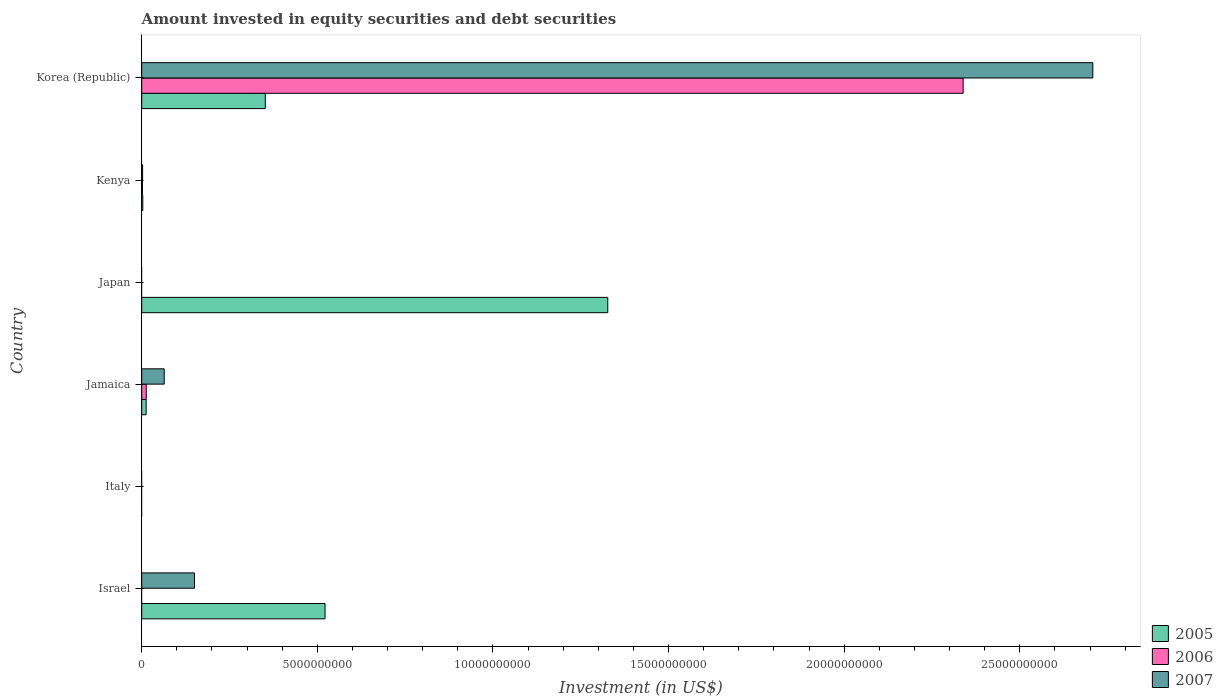How many bars are there on the 5th tick from the top?
Make the answer very short. 0. How many bars are there on the 2nd tick from the bottom?
Provide a succinct answer. 0. In how many cases, is the number of bars for a given country not equal to the number of legend labels?
Make the answer very short. 3. What is the amount invested in equity securities and debt securities in 2007 in Korea (Republic)?
Your answer should be compact. 2.71e+1. Across all countries, what is the maximum amount invested in equity securities and debt securities in 2007?
Provide a short and direct response. 2.71e+1. What is the total amount invested in equity securities and debt securities in 2005 in the graph?
Offer a terse response. 2.22e+1. What is the difference between the amount invested in equity securities and debt securities in 2005 in Japan and that in Kenya?
Provide a short and direct response. 1.32e+1. What is the difference between the amount invested in equity securities and debt securities in 2005 in Italy and the amount invested in equity securities and debt securities in 2007 in Korea (Republic)?
Provide a succinct answer. -2.71e+1. What is the average amount invested in equity securities and debt securities in 2006 per country?
Offer a terse response. 3.92e+09. What is the difference between the amount invested in equity securities and debt securities in 2007 and amount invested in equity securities and debt securities in 2006 in Kenya?
Your answer should be compact. 4.10e+06. In how many countries, is the amount invested in equity securities and debt securities in 2005 greater than 23000000000 US$?
Your answer should be compact. 0. What is the ratio of the amount invested in equity securities and debt securities in 2005 in Kenya to that in Korea (Republic)?
Your answer should be compact. 0.01. What is the difference between the highest and the second highest amount invested in equity securities and debt securities in 2005?
Offer a very short reply. 8.05e+09. What is the difference between the highest and the lowest amount invested in equity securities and debt securities in 2005?
Ensure brevity in your answer.  1.33e+1. How many bars are there?
Offer a terse response. 12. Are all the bars in the graph horizontal?
Make the answer very short. Yes. How many countries are there in the graph?
Give a very brief answer. 6. Does the graph contain grids?
Provide a succinct answer. No. How many legend labels are there?
Provide a succinct answer. 3. How are the legend labels stacked?
Give a very brief answer. Vertical. What is the title of the graph?
Offer a very short reply. Amount invested in equity securities and debt securities. Does "1965" appear as one of the legend labels in the graph?
Provide a short and direct response. No. What is the label or title of the X-axis?
Keep it short and to the point. Investment (in US$). What is the label or title of the Y-axis?
Keep it short and to the point. Country. What is the Investment (in US$) of 2005 in Israel?
Offer a terse response. 5.22e+09. What is the Investment (in US$) of 2006 in Israel?
Keep it short and to the point. 0. What is the Investment (in US$) in 2007 in Israel?
Ensure brevity in your answer.  1.50e+09. What is the Investment (in US$) of 2005 in Jamaica?
Keep it short and to the point. 1.26e+08. What is the Investment (in US$) of 2006 in Jamaica?
Your answer should be very brief. 1.29e+08. What is the Investment (in US$) of 2007 in Jamaica?
Offer a terse response. 6.40e+08. What is the Investment (in US$) in 2005 in Japan?
Keep it short and to the point. 1.33e+1. What is the Investment (in US$) in 2006 in Japan?
Your response must be concise. 0. What is the Investment (in US$) of 2005 in Kenya?
Offer a very short reply. 3.05e+07. What is the Investment (in US$) of 2006 in Kenya?
Make the answer very short. 2.06e+07. What is the Investment (in US$) of 2007 in Kenya?
Offer a very short reply. 2.47e+07. What is the Investment (in US$) of 2005 in Korea (Republic)?
Make the answer very short. 3.52e+09. What is the Investment (in US$) in 2006 in Korea (Republic)?
Offer a very short reply. 2.34e+1. What is the Investment (in US$) of 2007 in Korea (Republic)?
Provide a succinct answer. 2.71e+1. Across all countries, what is the maximum Investment (in US$) of 2005?
Ensure brevity in your answer.  1.33e+1. Across all countries, what is the maximum Investment (in US$) in 2006?
Offer a very short reply. 2.34e+1. Across all countries, what is the maximum Investment (in US$) in 2007?
Ensure brevity in your answer.  2.71e+1. Across all countries, what is the minimum Investment (in US$) in 2005?
Keep it short and to the point. 0. Across all countries, what is the minimum Investment (in US$) of 2007?
Make the answer very short. 0. What is the total Investment (in US$) of 2005 in the graph?
Your response must be concise. 2.22e+1. What is the total Investment (in US$) of 2006 in the graph?
Provide a succinct answer. 2.35e+1. What is the total Investment (in US$) in 2007 in the graph?
Your answer should be very brief. 2.92e+1. What is the difference between the Investment (in US$) in 2005 in Israel and that in Jamaica?
Give a very brief answer. 5.09e+09. What is the difference between the Investment (in US$) in 2007 in Israel and that in Jamaica?
Your answer should be very brief. 8.61e+08. What is the difference between the Investment (in US$) of 2005 in Israel and that in Japan?
Give a very brief answer. -8.05e+09. What is the difference between the Investment (in US$) of 2005 in Israel and that in Kenya?
Offer a very short reply. 5.19e+09. What is the difference between the Investment (in US$) in 2007 in Israel and that in Kenya?
Your answer should be very brief. 1.48e+09. What is the difference between the Investment (in US$) in 2005 in Israel and that in Korea (Republic)?
Ensure brevity in your answer.  1.70e+09. What is the difference between the Investment (in US$) of 2007 in Israel and that in Korea (Republic)?
Make the answer very short. -2.56e+1. What is the difference between the Investment (in US$) in 2005 in Jamaica and that in Japan?
Make the answer very short. -1.31e+1. What is the difference between the Investment (in US$) in 2005 in Jamaica and that in Kenya?
Ensure brevity in your answer.  9.55e+07. What is the difference between the Investment (in US$) in 2006 in Jamaica and that in Kenya?
Your answer should be very brief. 1.08e+08. What is the difference between the Investment (in US$) in 2007 in Jamaica and that in Kenya?
Offer a very short reply. 6.16e+08. What is the difference between the Investment (in US$) of 2005 in Jamaica and that in Korea (Republic)?
Ensure brevity in your answer.  -3.39e+09. What is the difference between the Investment (in US$) of 2006 in Jamaica and that in Korea (Republic)?
Ensure brevity in your answer.  -2.33e+1. What is the difference between the Investment (in US$) in 2007 in Jamaica and that in Korea (Republic)?
Your response must be concise. -2.64e+1. What is the difference between the Investment (in US$) in 2005 in Japan and that in Kenya?
Your answer should be compact. 1.32e+1. What is the difference between the Investment (in US$) in 2005 in Japan and that in Korea (Republic)?
Your answer should be compact. 9.75e+09. What is the difference between the Investment (in US$) of 2005 in Kenya and that in Korea (Republic)?
Offer a terse response. -3.49e+09. What is the difference between the Investment (in US$) of 2006 in Kenya and that in Korea (Republic)?
Give a very brief answer. -2.34e+1. What is the difference between the Investment (in US$) in 2007 in Kenya and that in Korea (Republic)?
Your response must be concise. -2.71e+1. What is the difference between the Investment (in US$) in 2005 in Israel and the Investment (in US$) in 2006 in Jamaica?
Keep it short and to the point. 5.09e+09. What is the difference between the Investment (in US$) in 2005 in Israel and the Investment (in US$) in 2007 in Jamaica?
Give a very brief answer. 4.58e+09. What is the difference between the Investment (in US$) in 2005 in Israel and the Investment (in US$) in 2006 in Kenya?
Make the answer very short. 5.20e+09. What is the difference between the Investment (in US$) of 2005 in Israel and the Investment (in US$) of 2007 in Kenya?
Offer a terse response. 5.19e+09. What is the difference between the Investment (in US$) in 2005 in Israel and the Investment (in US$) in 2006 in Korea (Republic)?
Your answer should be very brief. -1.82e+1. What is the difference between the Investment (in US$) of 2005 in Israel and the Investment (in US$) of 2007 in Korea (Republic)?
Offer a terse response. -2.19e+1. What is the difference between the Investment (in US$) of 2005 in Jamaica and the Investment (in US$) of 2006 in Kenya?
Your response must be concise. 1.05e+08. What is the difference between the Investment (in US$) in 2005 in Jamaica and the Investment (in US$) in 2007 in Kenya?
Ensure brevity in your answer.  1.01e+08. What is the difference between the Investment (in US$) of 2006 in Jamaica and the Investment (in US$) of 2007 in Kenya?
Offer a terse response. 1.04e+08. What is the difference between the Investment (in US$) of 2005 in Jamaica and the Investment (in US$) of 2006 in Korea (Republic)?
Ensure brevity in your answer.  -2.33e+1. What is the difference between the Investment (in US$) of 2005 in Jamaica and the Investment (in US$) of 2007 in Korea (Republic)?
Give a very brief answer. -2.70e+1. What is the difference between the Investment (in US$) of 2006 in Jamaica and the Investment (in US$) of 2007 in Korea (Republic)?
Make the answer very short. -2.69e+1. What is the difference between the Investment (in US$) of 2005 in Japan and the Investment (in US$) of 2006 in Kenya?
Provide a short and direct response. 1.32e+1. What is the difference between the Investment (in US$) of 2005 in Japan and the Investment (in US$) of 2007 in Kenya?
Your answer should be very brief. 1.32e+1. What is the difference between the Investment (in US$) in 2005 in Japan and the Investment (in US$) in 2006 in Korea (Republic)?
Your answer should be very brief. -1.01e+1. What is the difference between the Investment (in US$) in 2005 in Japan and the Investment (in US$) in 2007 in Korea (Republic)?
Ensure brevity in your answer.  -1.38e+1. What is the difference between the Investment (in US$) in 2005 in Kenya and the Investment (in US$) in 2006 in Korea (Republic)?
Offer a very short reply. -2.34e+1. What is the difference between the Investment (in US$) in 2005 in Kenya and the Investment (in US$) in 2007 in Korea (Republic)?
Keep it short and to the point. -2.70e+1. What is the difference between the Investment (in US$) of 2006 in Kenya and the Investment (in US$) of 2007 in Korea (Republic)?
Provide a short and direct response. -2.71e+1. What is the average Investment (in US$) in 2005 per country?
Offer a very short reply. 3.69e+09. What is the average Investment (in US$) in 2006 per country?
Ensure brevity in your answer.  3.92e+09. What is the average Investment (in US$) of 2007 per country?
Offer a terse response. 4.87e+09. What is the difference between the Investment (in US$) in 2005 and Investment (in US$) in 2007 in Israel?
Provide a succinct answer. 3.72e+09. What is the difference between the Investment (in US$) of 2005 and Investment (in US$) of 2006 in Jamaica?
Your answer should be compact. -2.52e+06. What is the difference between the Investment (in US$) of 2005 and Investment (in US$) of 2007 in Jamaica?
Provide a succinct answer. -5.14e+08. What is the difference between the Investment (in US$) in 2006 and Investment (in US$) in 2007 in Jamaica?
Your response must be concise. -5.12e+08. What is the difference between the Investment (in US$) in 2005 and Investment (in US$) in 2006 in Kenya?
Provide a short and direct response. 9.84e+06. What is the difference between the Investment (in US$) of 2005 and Investment (in US$) of 2007 in Kenya?
Offer a very short reply. 5.74e+06. What is the difference between the Investment (in US$) of 2006 and Investment (in US$) of 2007 in Kenya?
Your answer should be very brief. -4.10e+06. What is the difference between the Investment (in US$) in 2005 and Investment (in US$) in 2006 in Korea (Republic)?
Your answer should be compact. -1.99e+1. What is the difference between the Investment (in US$) of 2005 and Investment (in US$) of 2007 in Korea (Republic)?
Make the answer very short. -2.36e+1. What is the difference between the Investment (in US$) in 2006 and Investment (in US$) in 2007 in Korea (Republic)?
Keep it short and to the point. -3.69e+09. What is the ratio of the Investment (in US$) of 2005 in Israel to that in Jamaica?
Your answer should be very brief. 41.42. What is the ratio of the Investment (in US$) of 2007 in Israel to that in Jamaica?
Your response must be concise. 2.34. What is the ratio of the Investment (in US$) of 2005 in Israel to that in Japan?
Ensure brevity in your answer.  0.39. What is the ratio of the Investment (in US$) in 2005 in Israel to that in Kenya?
Give a very brief answer. 171.32. What is the ratio of the Investment (in US$) in 2007 in Israel to that in Kenya?
Offer a terse response. 60.73. What is the ratio of the Investment (in US$) in 2005 in Israel to that in Korea (Republic)?
Make the answer very short. 1.48. What is the ratio of the Investment (in US$) in 2007 in Israel to that in Korea (Republic)?
Provide a short and direct response. 0.06. What is the ratio of the Investment (in US$) in 2005 in Jamaica to that in Japan?
Give a very brief answer. 0.01. What is the ratio of the Investment (in US$) of 2005 in Jamaica to that in Kenya?
Provide a short and direct response. 4.14. What is the ratio of the Investment (in US$) of 2006 in Jamaica to that in Kenya?
Keep it short and to the point. 6.23. What is the ratio of the Investment (in US$) of 2007 in Jamaica to that in Kenya?
Your response must be concise. 25.9. What is the ratio of the Investment (in US$) in 2005 in Jamaica to that in Korea (Republic)?
Your answer should be very brief. 0.04. What is the ratio of the Investment (in US$) in 2006 in Jamaica to that in Korea (Republic)?
Provide a short and direct response. 0.01. What is the ratio of the Investment (in US$) in 2007 in Jamaica to that in Korea (Republic)?
Your response must be concise. 0.02. What is the ratio of the Investment (in US$) of 2005 in Japan to that in Kenya?
Your answer should be very brief. 435.55. What is the ratio of the Investment (in US$) of 2005 in Japan to that in Korea (Republic)?
Your answer should be compact. 3.77. What is the ratio of the Investment (in US$) in 2005 in Kenya to that in Korea (Republic)?
Your response must be concise. 0.01. What is the ratio of the Investment (in US$) in 2006 in Kenya to that in Korea (Republic)?
Provide a succinct answer. 0. What is the ratio of the Investment (in US$) in 2007 in Kenya to that in Korea (Republic)?
Offer a terse response. 0. What is the difference between the highest and the second highest Investment (in US$) of 2005?
Give a very brief answer. 8.05e+09. What is the difference between the highest and the second highest Investment (in US$) in 2006?
Provide a succinct answer. 2.33e+1. What is the difference between the highest and the second highest Investment (in US$) in 2007?
Ensure brevity in your answer.  2.56e+1. What is the difference between the highest and the lowest Investment (in US$) in 2005?
Provide a succinct answer. 1.33e+1. What is the difference between the highest and the lowest Investment (in US$) in 2006?
Offer a terse response. 2.34e+1. What is the difference between the highest and the lowest Investment (in US$) of 2007?
Keep it short and to the point. 2.71e+1. 